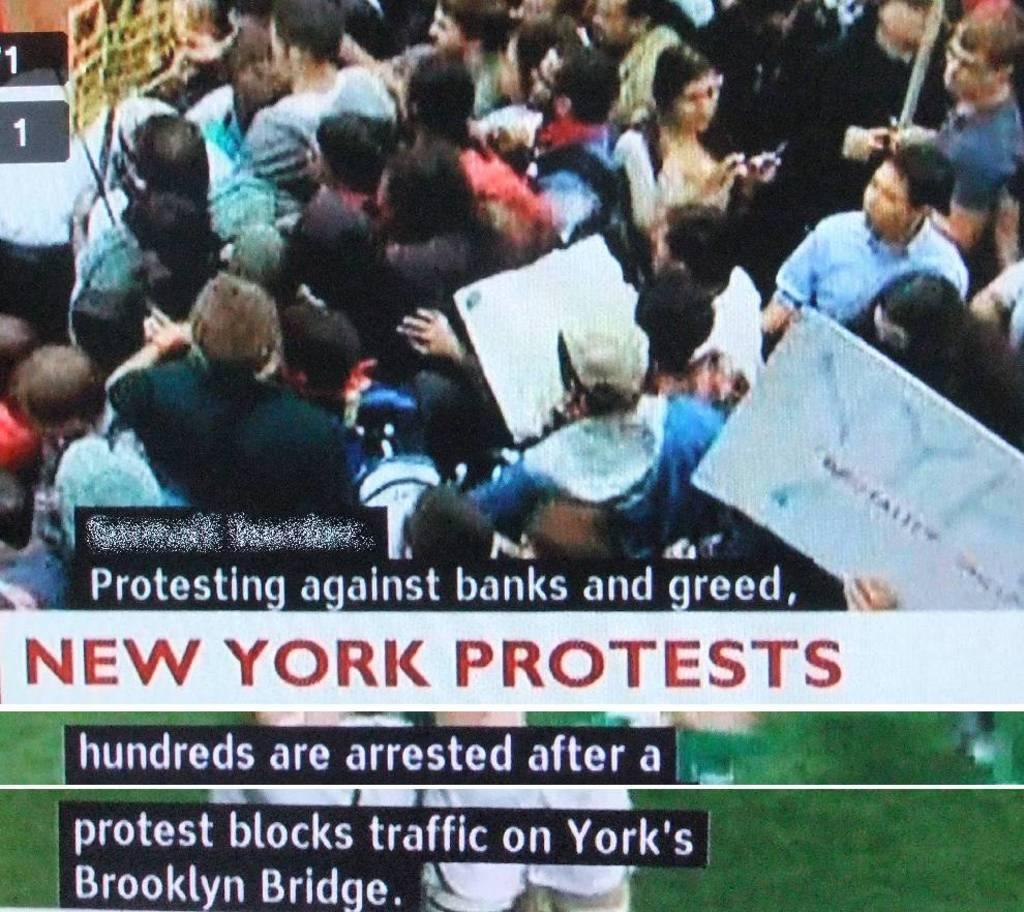Please provide a concise description of this image. Here in this picture we can see a headline news getting telecast in television and we can see people protesting with ply cards over there and we can see some text also written below it. 